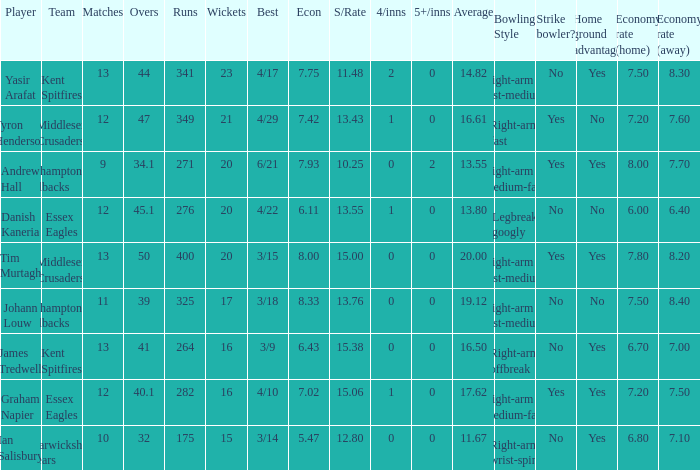Name the least matches for runs being 276 12.0. 